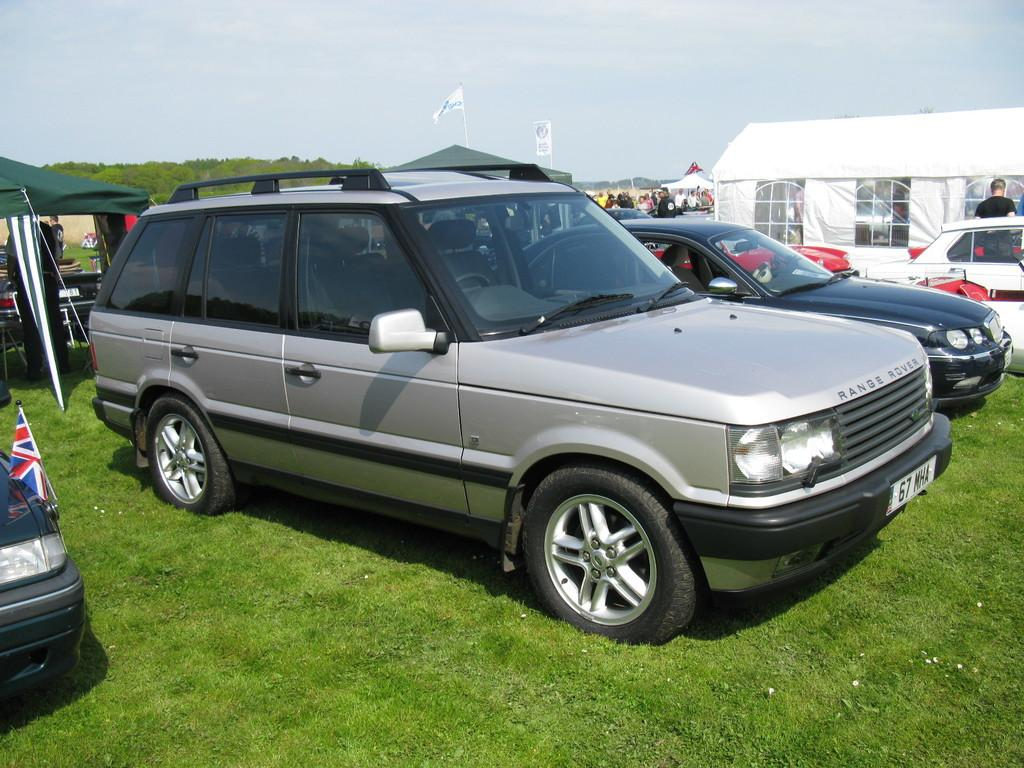What type of vehicles can be seen on the ground in the image? There are cars on the ground in the image. What other objects can be seen in the image besides cars? There are trees and poles in the image. What kind of structure is present in the image? There is a tent-like structure in the image. What color is the curtain hanging in the image? There is no curtain present in the image. 